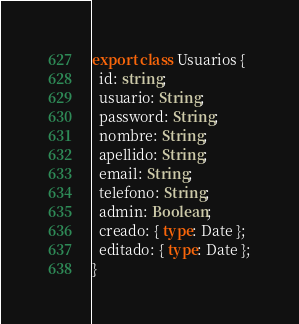Convert code to text. <code><loc_0><loc_0><loc_500><loc_500><_TypeScript_>export class Usuarios {
  id: string;
  usuario: String;
  password: String;
  nombre: String;
  apellido: String;
  email: String;
  telefono: String;
  admin: Boolean;
  creado: { type: Date };
  editado: { type: Date };
}
</code> 